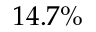Convert formula to latex. <formula><loc_0><loc_0><loc_500><loc_500>1 4 . 7 \%</formula> 